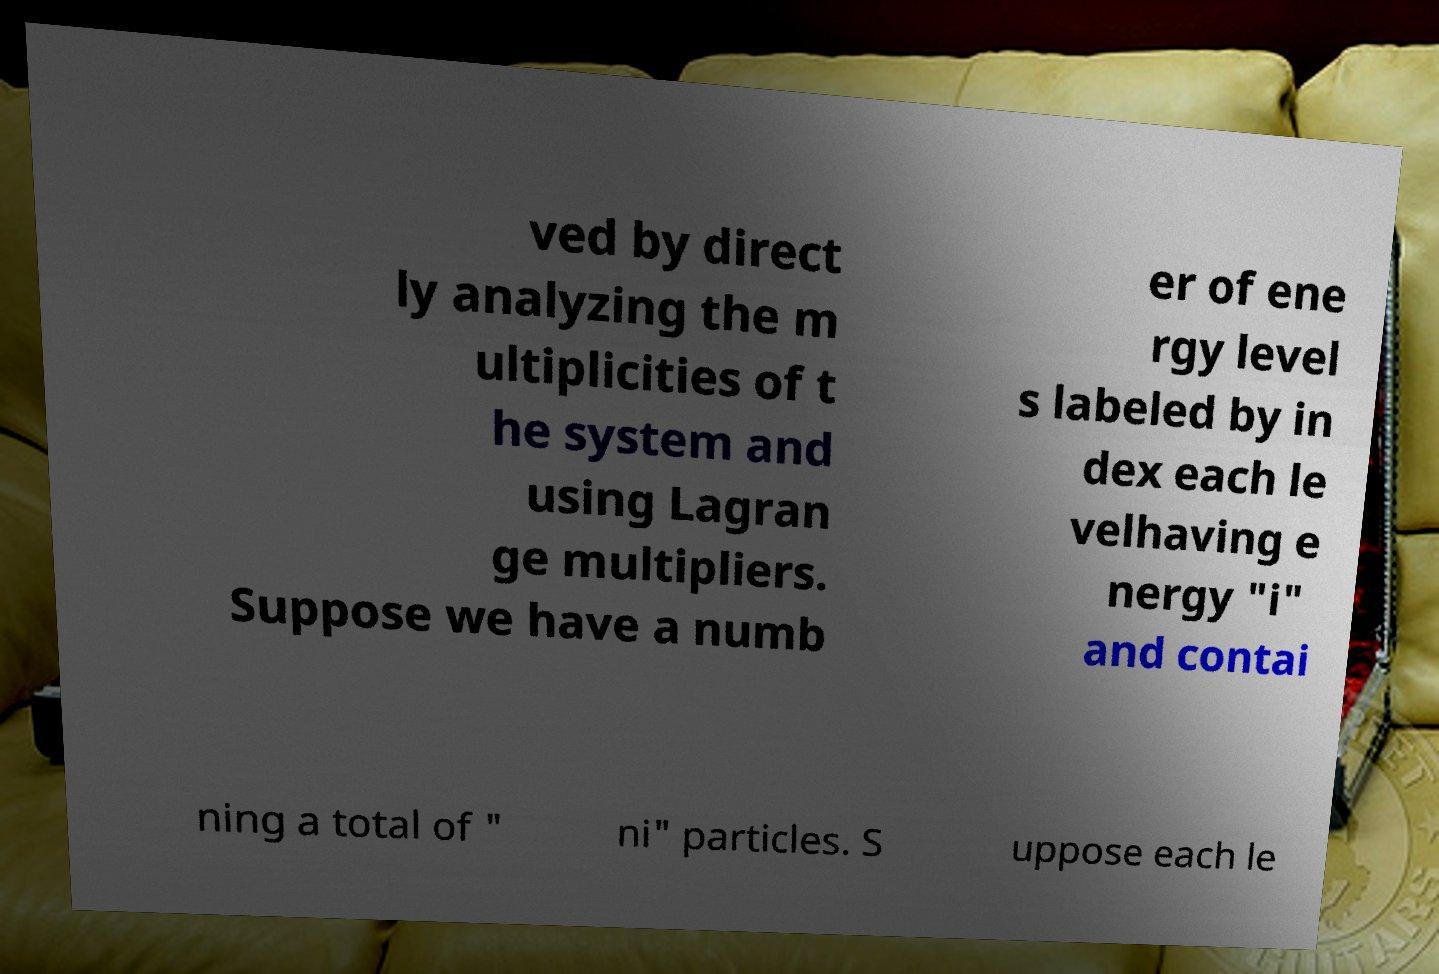What messages or text are displayed in this image? I need them in a readable, typed format. ved by direct ly analyzing the m ultiplicities of t he system and using Lagran ge multipliers. Suppose we have a numb er of ene rgy level s labeled by in dex each le velhaving e nergy "i" and contai ning a total of " ni" particles. S uppose each le 